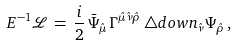Convert formula to latex. <formula><loc_0><loc_0><loc_500><loc_500>E ^ { - 1 } \mathcal { L } \, = \, \frac { i } { 2 } \, \bar { \Psi } _ { \hat { \mu } } \, \Gamma ^ { \hat { \mu } \hat { \nu } \hat { \rho } } \, \triangle d o w n _ { \hat { \nu } } \Psi _ { \hat { \rho } } \, ,</formula> 